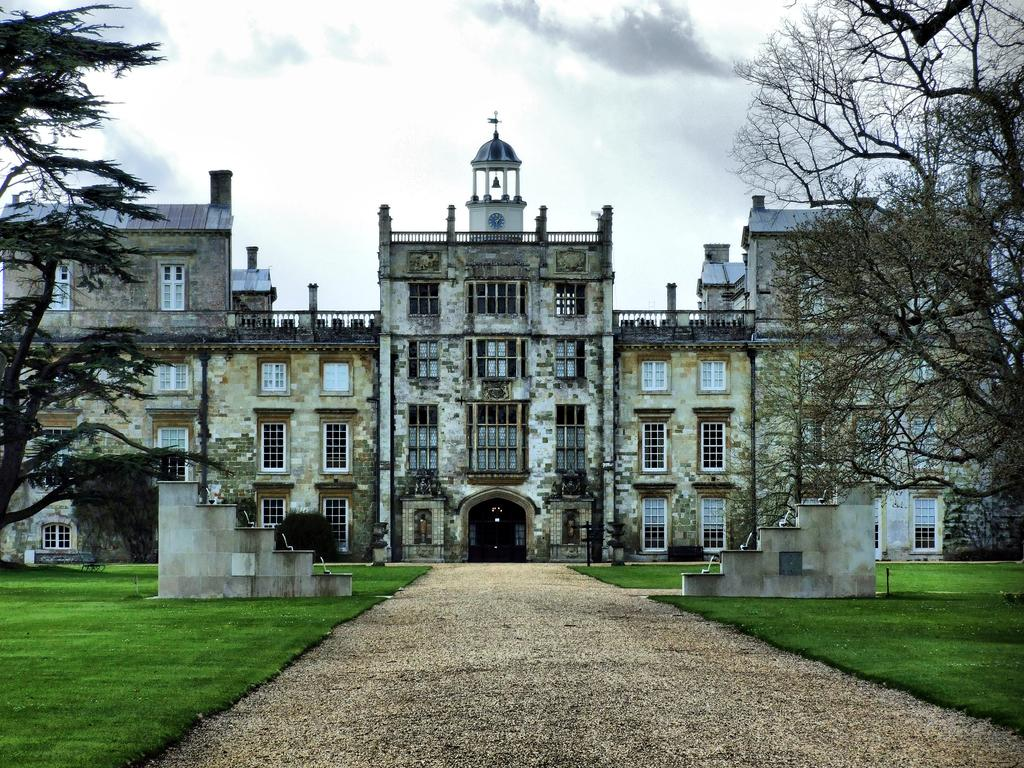What type of building is in the center of the image? There is a Wilton house in the center of the image. What architectural feature can be seen in the image? There are stairs in the image. What type of vegetation is present in the image? There are trees in the image. What type of terrain is visible on both sides of the image? There is grassland on the right side of the image and grassland on the left side of the image. How many eyes can be seen on the tree in the image? There are no eyes present on the tree in the image, as trees do not have eyes. 